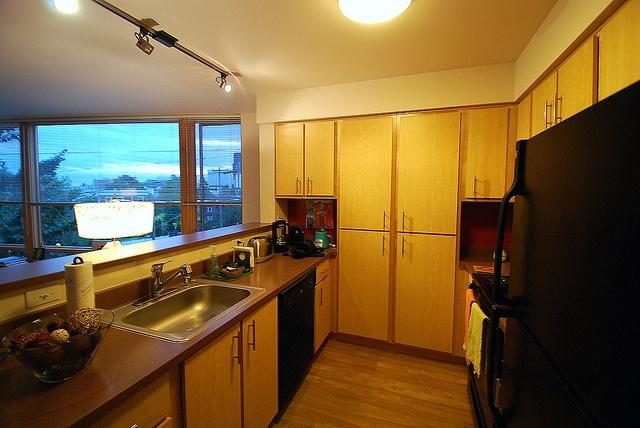Describe the objects in this image and their specific colors. I can see refrigerator in gray, black, maroon, orange, and red tones, sink in gray, maroon, and olive tones, bowl in gray, black, maroon, and olive tones, oven in gray, black, olive, and maroon tones, and toaster in gray, black, maroon, and olive tones in this image. 